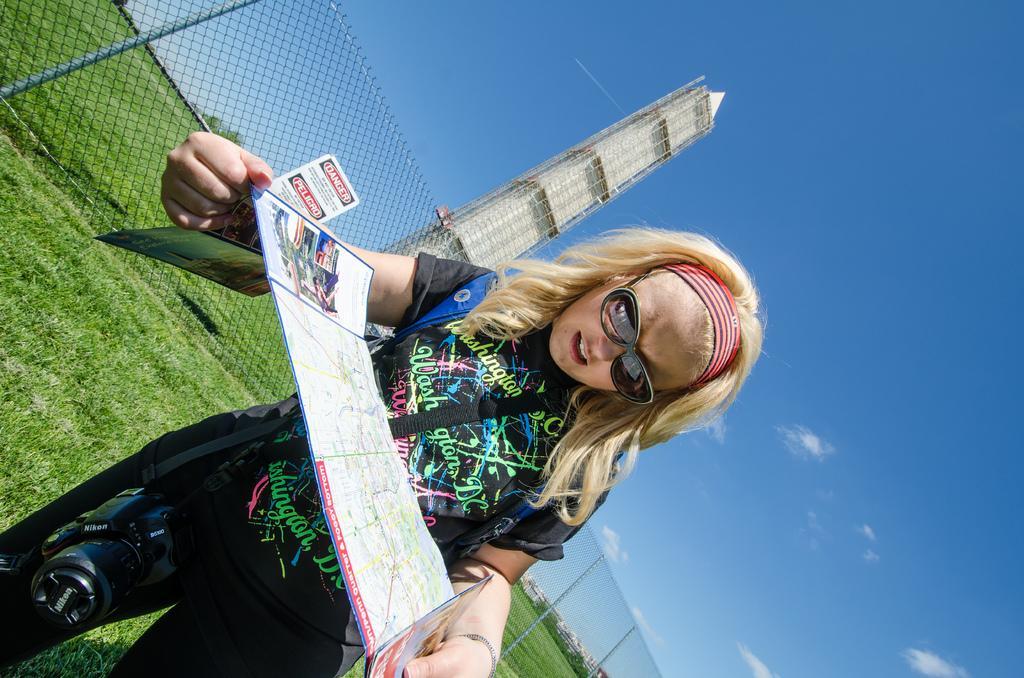In one or two sentences, can you explain what this image depicts? In this picture I can see a woman standing she is holding a paper in her hands and she is holding a camera with the help of a belt and she wore spectacles and I can see buildings and grass on the ground and I can see few trees and a blue cloudy sky and I can see a tower and a metal fence. 